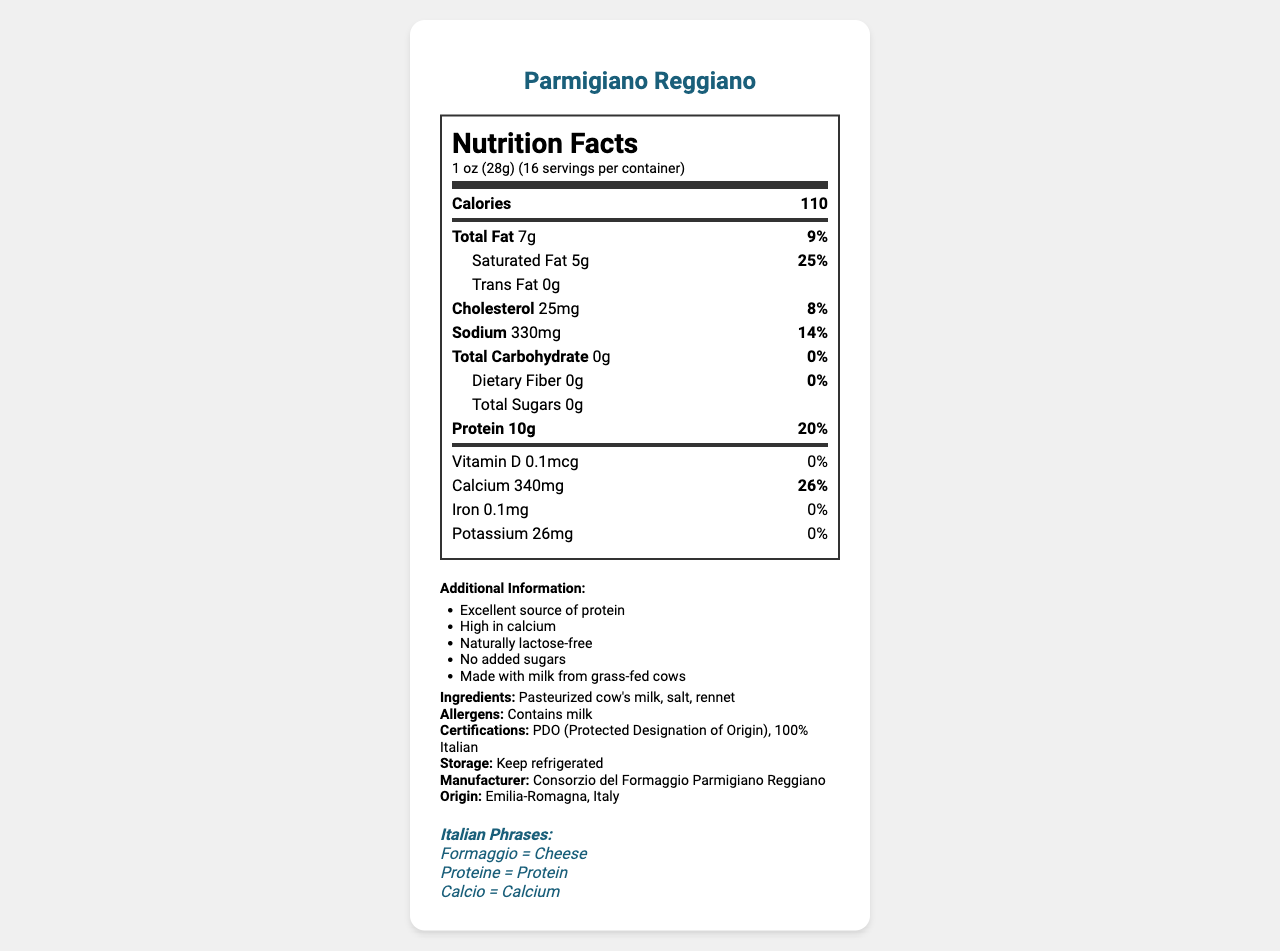What is the protein content in one serving of Parmigiano Reggiano? The protein content is listed as 10g under the "Protein" section.
Answer: 10g How much calcium is in one serving, and what percentage of the daily value does it represent? The calcium content is listed as 340mg which represents 26% of the daily value.
Answer: 340mg, 26% What are the total fat and saturated fat contents per serving? The total fat is listed as 7g and saturated fat is listed as 5g per serving.
Answer: Total Fat: 7g, Saturated Fat: 5g How many calories are in one serving of Parmigiano Reggiano? The calorie content per serving is listed as 110.
Answer: 110 What is the serving size and how many servings are there per container? The serving size is 1 oz (28g) and there are 16 servings per container.
Answer: 1 oz (28g), 16 servings What is one of the additional benefits of Parmigiano Reggiano according to the document? A. Source of Vitamin C B. High in Fiber C. Excellent source of protein The document lists "Excellent source of protein" as part of the additional information.
Answer: C. Excellent source of protein Which certification does Parmigiano Reggiano have that ensures its authenticity? A. USDA Organic B. PDO (Protected Designation of Origin) C. Fair Trade The certification listed in the document is PDO (Protected Designation of Origin).
Answer: B. PDO (Protected Designation of Origin) Does Parmigiano Reggiano contain any dietary fiber? The dietary fiber content is listed as 0g.
Answer: No Is Parmigiano Reggiano naturally lactose-free? The document mentions that it is naturally lactose-free under additional information.
Answer: Yes Give a brief summary of the Parmigiano Reggiano nutrition label and key information. The summary captures the key nutritional values, additional benefits, and identifying certifications and origin of the cheese.
Answer: Parmigiano Reggiano is a traditional Italian cheese, rich in protein (10g per serving) and calcium (340mg per serving, 26% DV). It contains 110 calories per serving, with 7g of total fat and 5g of saturated fat. The cheese is naturally lactose-free, contains no added sugars, and is made from milk from grass-fed cows. It has certifications like PDO (Protected Designation of Origin) and is produced in Emilia-Romagna, Italy. Where is Parmigiano Reggiano manufactured? The place of manufacture is listed as Emilia-Romagna, Italy.
Answer: Emilia-Romagna, Italy What is the cholesterol content in one serving? The cholesterol content is 25mg which represents 8% of the daily value.
Answer: 25mg, 8% What is the origin of the milk used to produce Parmigiano Reggiano? The document does not provide specific information about the origin of the milk, other than it is from grass-fed cows.
Answer: I don’t know What is the percentage of daily value for sodium in one serving of Parmigiano Reggiano? The sodium content per serving is 330mg which represents 14% of the daily value.
Answer: 14% 